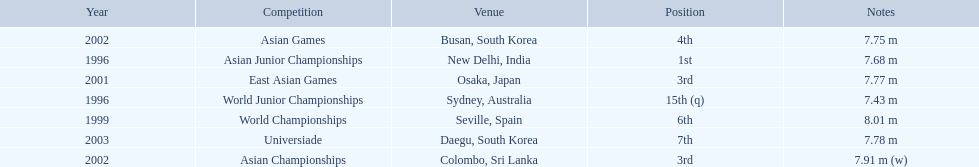I'm looking to parse the entire table for insights. Could you assist me with that? {'header': ['Year', 'Competition', 'Venue', 'Position', 'Notes'], 'rows': [['2002', 'Asian Games', 'Busan, South Korea', '4th', '7.75 m'], ['1996', 'Asian Junior Championships', 'New Delhi, India', '1st', '7.68 m'], ['2001', 'East Asian Games', 'Osaka, Japan', '3rd', '7.77 m'], ['1996', 'World Junior Championships', 'Sydney, Australia', '15th (q)', '7.43 m'], ['1999', 'World Championships', 'Seville, Spain', '6th', '8.01 m'], ['2003', 'Universiade', 'Daegu, South Korea', '7th', '7.78 m'], ['2002', 'Asian Championships', 'Colombo, Sri Lanka', '3rd', '7.91 m (w)']]} What are all of the competitions? World Junior Championships, Asian Junior Championships, World Championships, East Asian Games, Asian Championships, Asian Games, Universiade. What was his positions in these competitions? 15th (q), 1st, 6th, 3rd, 3rd, 4th, 7th. And during which competition did he reach 1st place? Asian Junior Championships. 